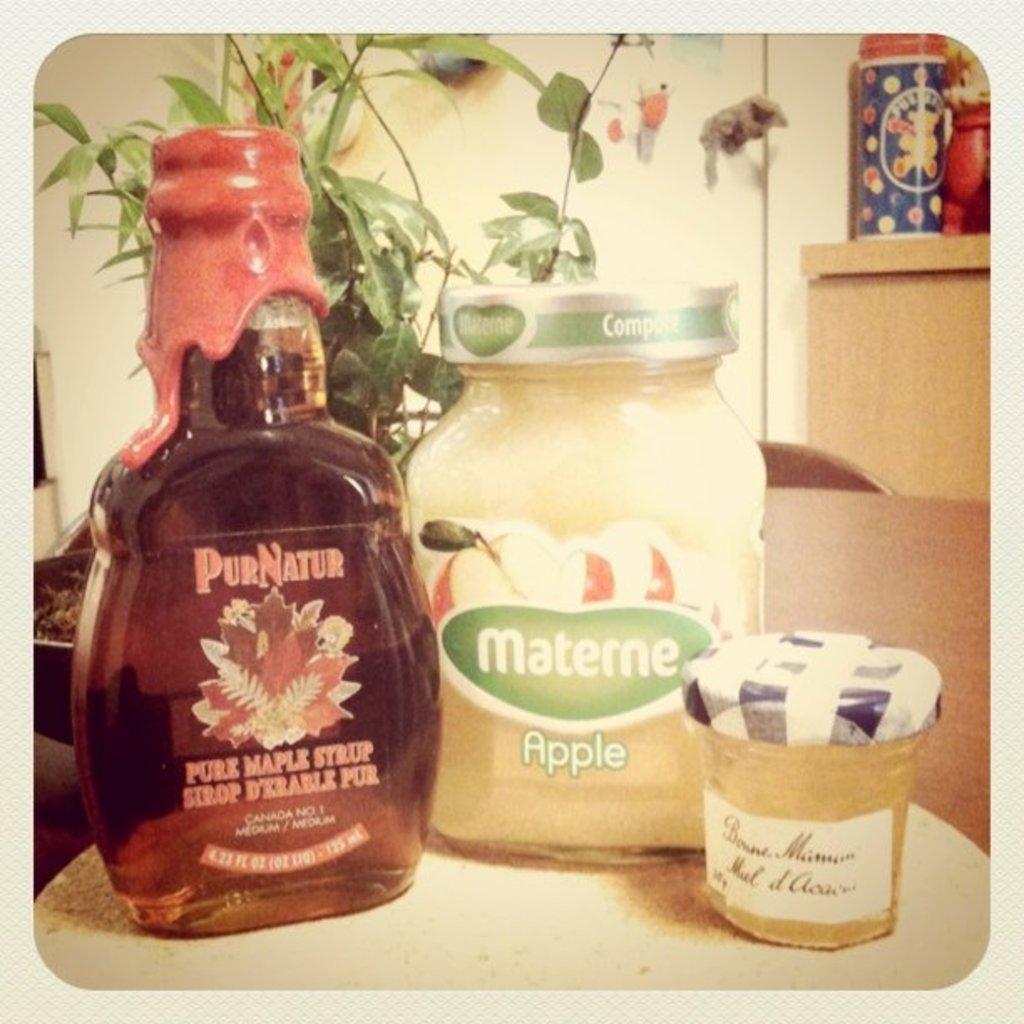Describe this image in one or two sentences. As we can see in the image there is a wall, plant and table. On table there is bottle, glass and box. 